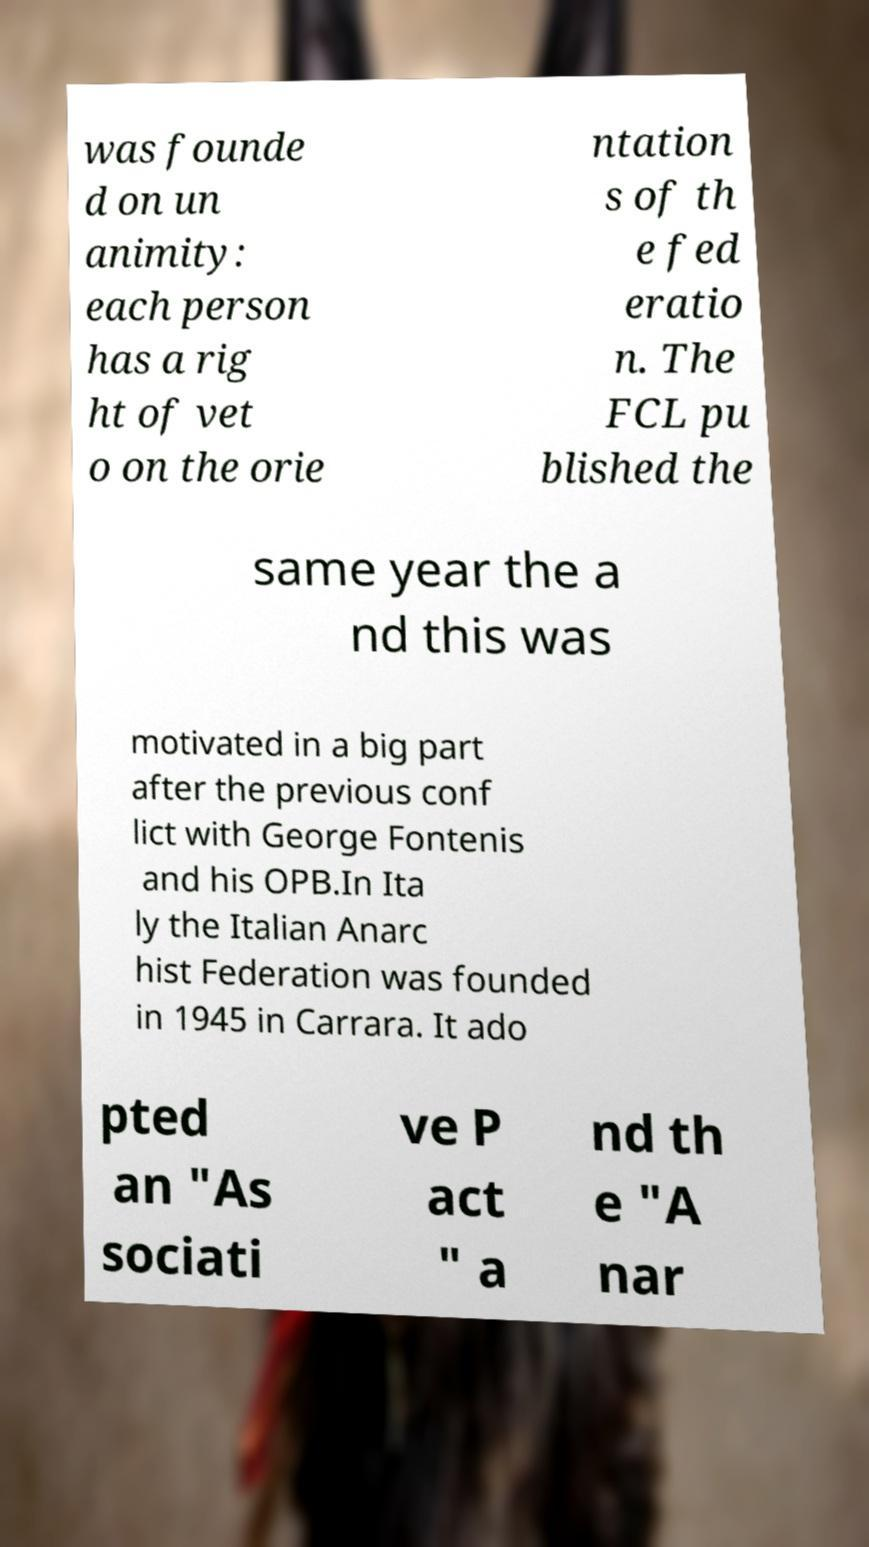Can you read and provide the text displayed in the image?This photo seems to have some interesting text. Can you extract and type it out for me? was founde d on un animity: each person has a rig ht of vet o on the orie ntation s of th e fed eratio n. The FCL pu blished the same year the a nd this was motivated in a big part after the previous conf lict with George Fontenis and his OPB.In Ita ly the Italian Anarc hist Federation was founded in 1945 in Carrara. It ado pted an "As sociati ve P act " a nd th e "A nar 